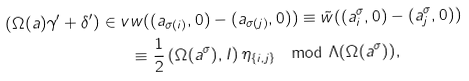Convert formula to latex. <formula><loc_0><loc_0><loc_500><loc_500>( \Omega ( a ) \gamma ^ { \prime } + \delta ^ { \prime } ) \in v & w ( ( a _ { \sigma ( i ) } , 0 ) - ( a _ { \sigma ( j ) } , 0 ) ) \equiv \tilde { w } ( ( a _ { i } ^ { \sigma } , 0 ) - ( a _ { j } ^ { \sigma } , 0 ) ) \\ & \equiv \frac { 1 } { 2 } \left ( \Omega ( a ^ { \sigma } ) , I \right ) \eta _ { \{ i , j \} } \mod \Lambda ( \Omega ( a ^ { \sigma } ) ) ,</formula> 